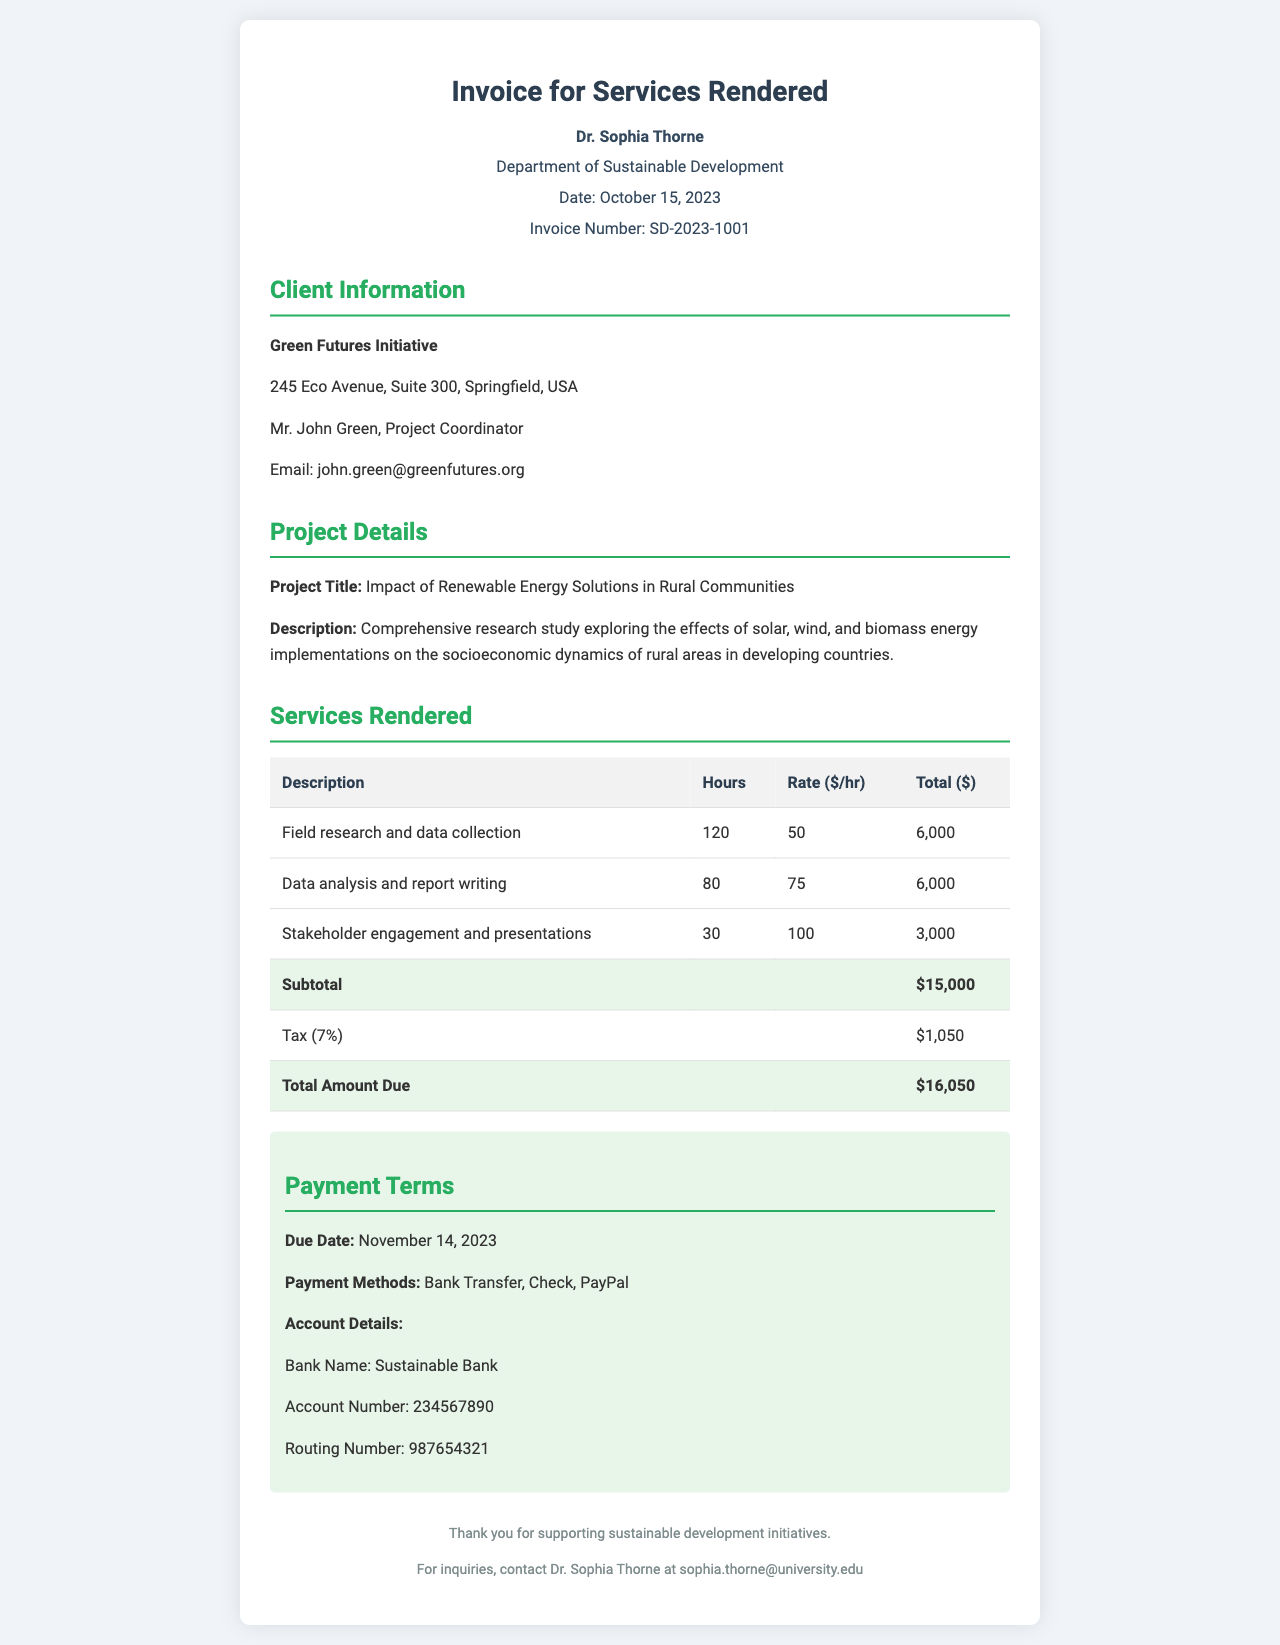What is the date of the invoice? The date of the invoice is mentioned at the top of the document as October 15, 2023.
Answer: October 15, 2023 Who is the client? The client's name is provided in the client information section as Green Futures Initiative.
Answer: Green Futures Initiative What is the total amount due? The total amount due is calculated at the end of the services rendered section, which states $16,050.
Answer: $16,050 How many hours were spent on field research and data collection? The document lists the hours spent on field research and data collection in the services rendered table as 120 hours.
Answer: 120 What is the rate per hour for data analysis and report writing? The invoice specifies the rate for data analysis and report writing as $75 per hour in the services rendered table.
Answer: $75 What is the due date for payment? The due date for payment is clearly stated in the payment terms section as November 14, 2023.
Answer: November 14, 2023 Who is the project coordinator? The project coordinator's name is mentioned in the client information section as Mr. John Green.
Answer: Mr. John Green What types of energy solutions are explored in the project? The project explores solar, wind, and biomass energy solutions as indicated in the project details section.
Answer: Solar, wind, and biomass What is the tax rate applied to the invoice? The tax rate applied to the invoice is given as 7% in the services rendered section.
Answer: 7% 